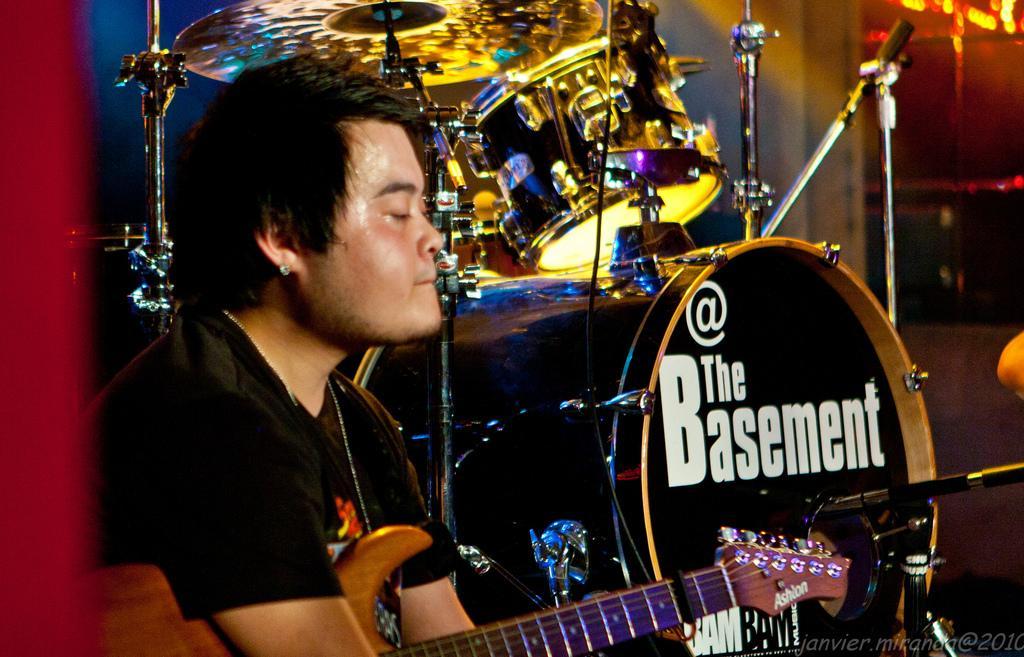Please provide a concise description of this image. In this image the man on the left side is holding a guitar in his hand. In the background there is a musical instrument. On the instrument where is the word @ the basement. 